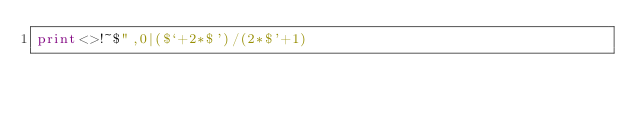Convert code to text. <code><loc_0><loc_0><loc_500><loc_500><_Perl_>print<>!~$",0|($`+2*$')/(2*$'+1)</code> 